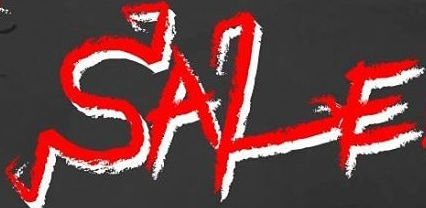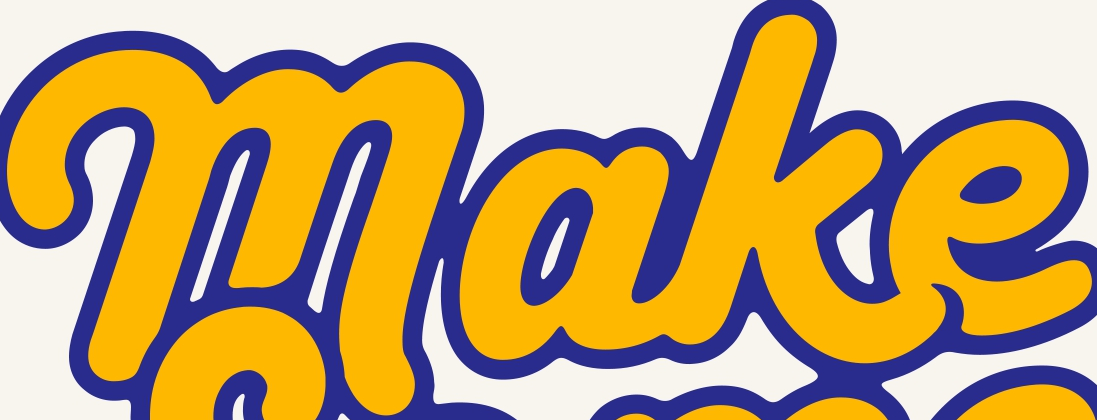What text is displayed in these images sequentially, separated by a semicolon? SALE; make 